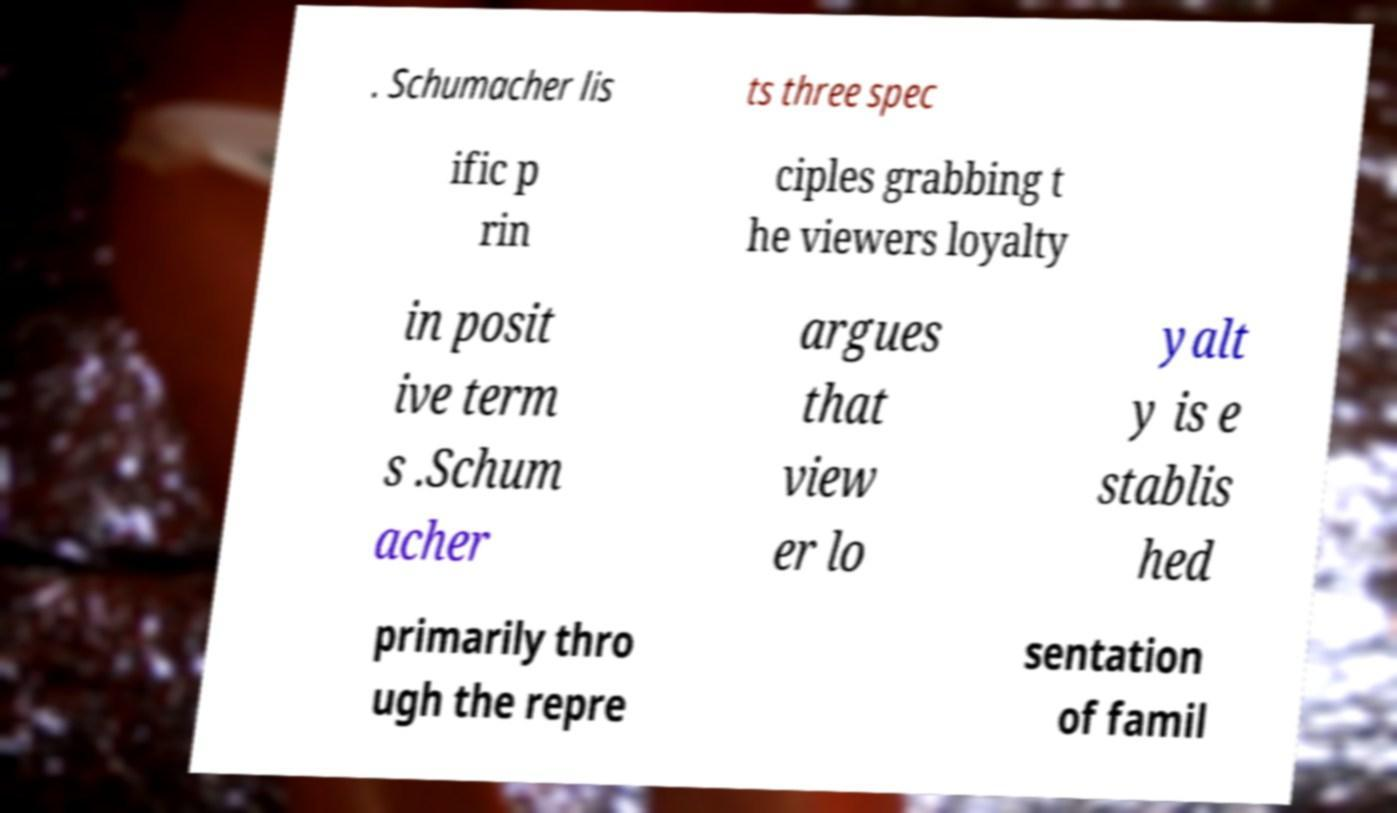What messages or text are displayed in this image? I need them in a readable, typed format. . Schumacher lis ts three spec ific p rin ciples grabbing t he viewers loyalty in posit ive term s .Schum acher argues that view er lo yalt y is e stablis hed primarily thro ugh the repre sentation of famil 